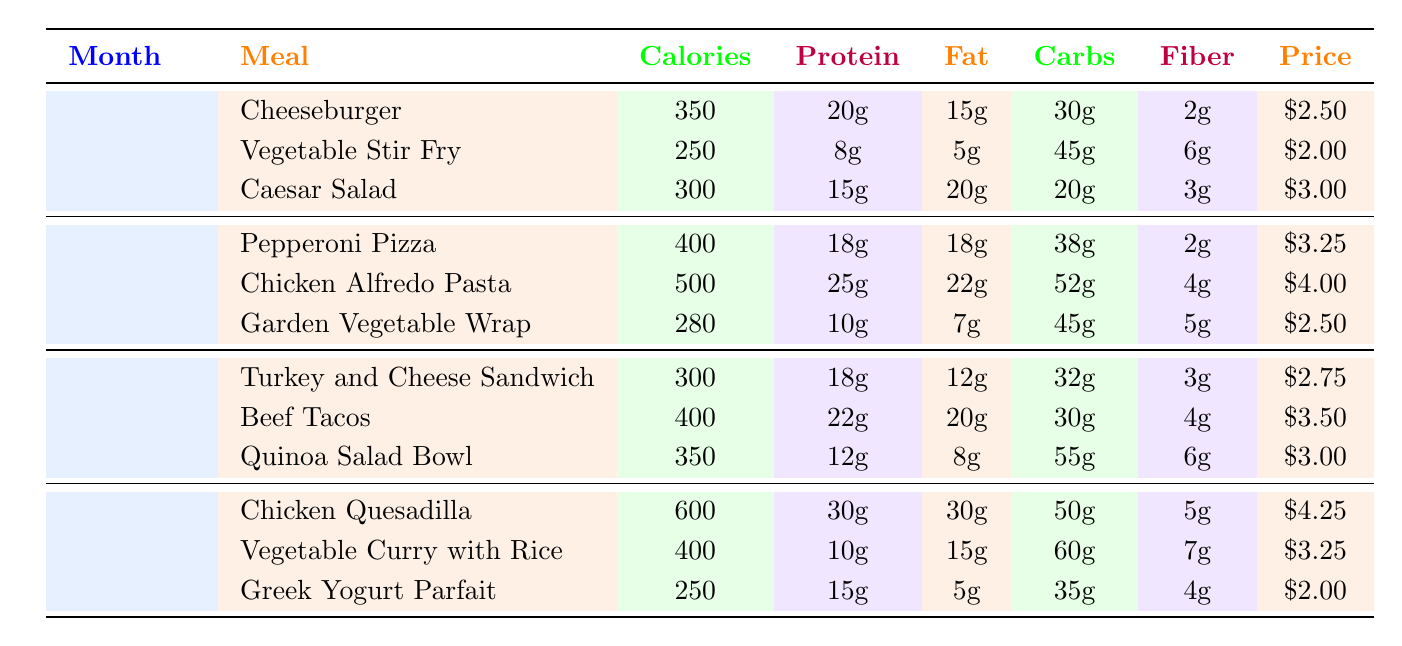What is the price of the Chicken Alfredo Pasta in October? The table shows that in the month of October, the Chicken Alfredo Pasta option is listed, and its price is noted next to it. According to the table, the price of Chicken Alfredo Pasta is $4.00.
Answer: $4.00 Which meal option has the highest calories in December? By examining the December section of the table, we can compare the calorie values of all meals provided. The Chicken Quesadilla has 600 calories, which is higher than any other meal listed for December.
Answer: Chicken Quesadilla How many grams of protein does the Beef Tacos contain? Looking at the November section, the Beef Tacos meal option states that it contains 22 grams of protein included in the nutritional information.
Answer: 22g What is the average calorie count of the meals offered in September? The calorie counts for the September meals are 350 for Cheeseburger, 250 for Vegetable Stir Fry, and 300 for Caesar Salad. To find the average, we sum these values: 350 + 250 + 300 = 900 calories. Then, we divide by the number of meals, which is 3: 900 / 3 = 300.
Answer: 300 Is the Vegetarian option mentioned in the October menu? The table shows that the Garden Vegetable Wrap is included in the October options, which can be classified as a vegetarian meal. Therefore, there is a vegetarian option available in October.
Answer: Yes Which meal in November has the least amount of fat? By observing the fat content of the meals in November, the Turkey and Cheese Sandwich contains 12 grams of fat, Beef Tacos contain 20 grams, and Quinoa Salad Bowl contains 8 grams. Thus, the Quinoa Salad Bowl has the least amount of fat with 8 grams.
Answer: Quinoa Salad Bowl What is the total price of all meals offered in December? The prices for December meals are $4.25 for Chicken Quesadilla, $3.25 for Vegetable Curry with Rice, and $2.00 for Greek Yogurt Parfait. Adding these up gives $4.25 + $3.25 + $2.00 = $9.50 as the total price for all meals offered in December.
Answer: $9.50 Which meal has the highest fat content in October? In October, the three meal options are Pepperoni Pizza (18g), Chicken Alfredo Pasta (22g), and Garden Vegetable Wrap (7g). By comparing these fat values, Chicken Alfredo Pasta has the highest fat content at 22 grams.
Answer: Chicken Alfredo Pasta 